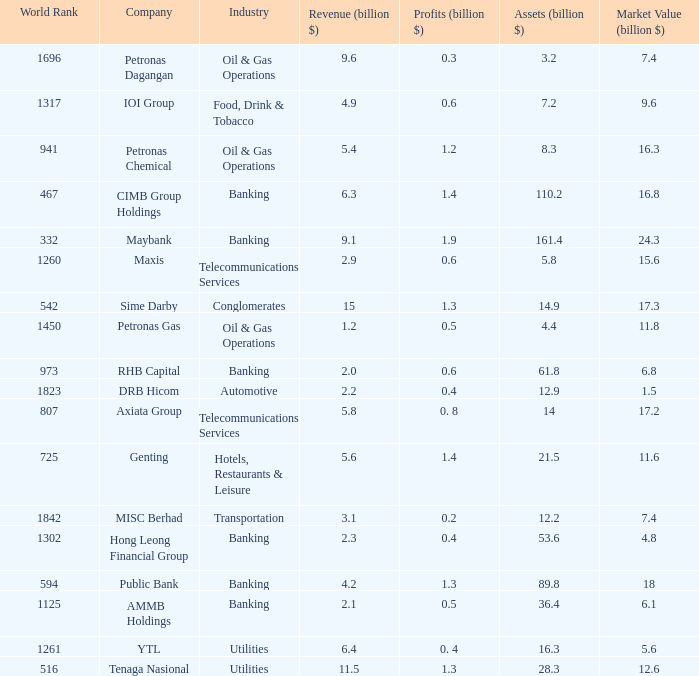Name the profits for market value of 11.8 0.5. 